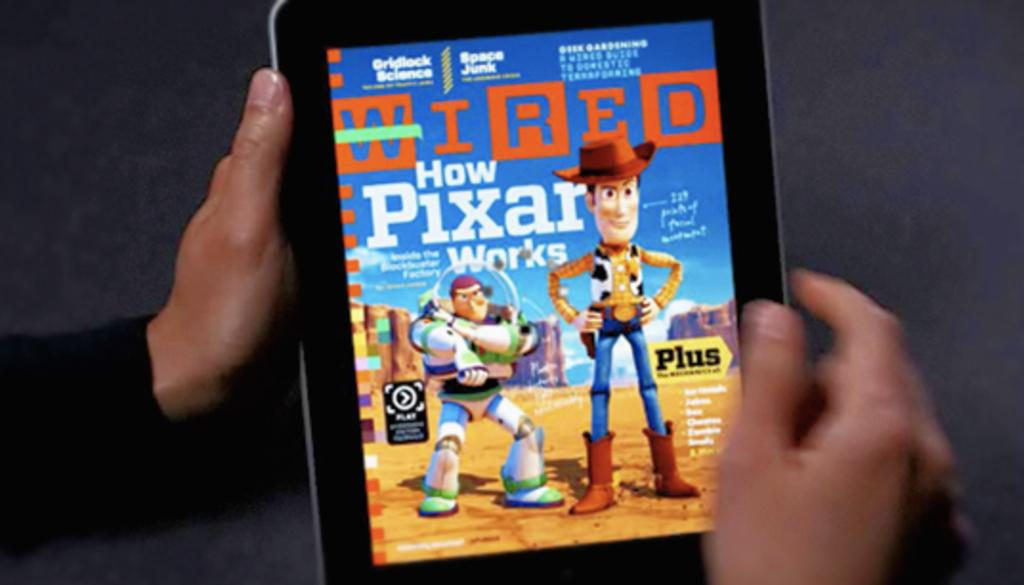Who is present in the image? There is a person in the image. What is the person holding in the image? The person is holding a tablet. What can be seen on the tablet's screen? There are toy images on the tablet's screen. What type of soda is the person drinking in the image? There is no soda present in the image; the person is holding a tablet with toy images on the screen. 